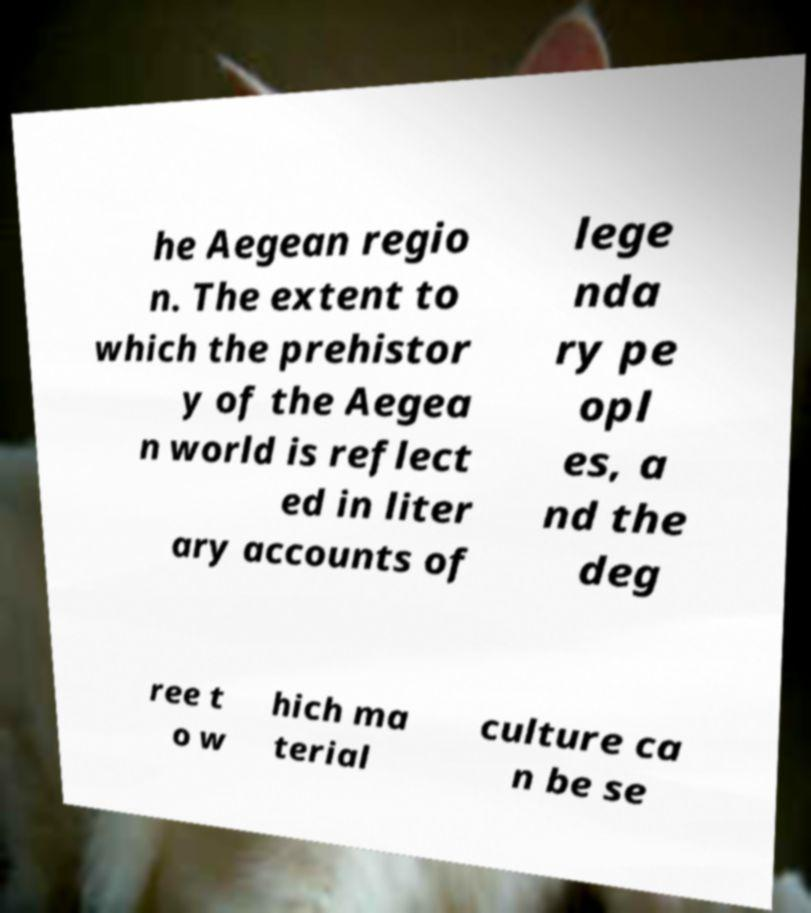Can you accurately transcribe the text from the provided image for me? he Aegean regio n. The extent to which the prehistor y of the Aegea n world is reflect ed in liter ary accounts of lege nda ry pe opl es, a nd the deg ree t o w hich ma terial culture ca n be se 